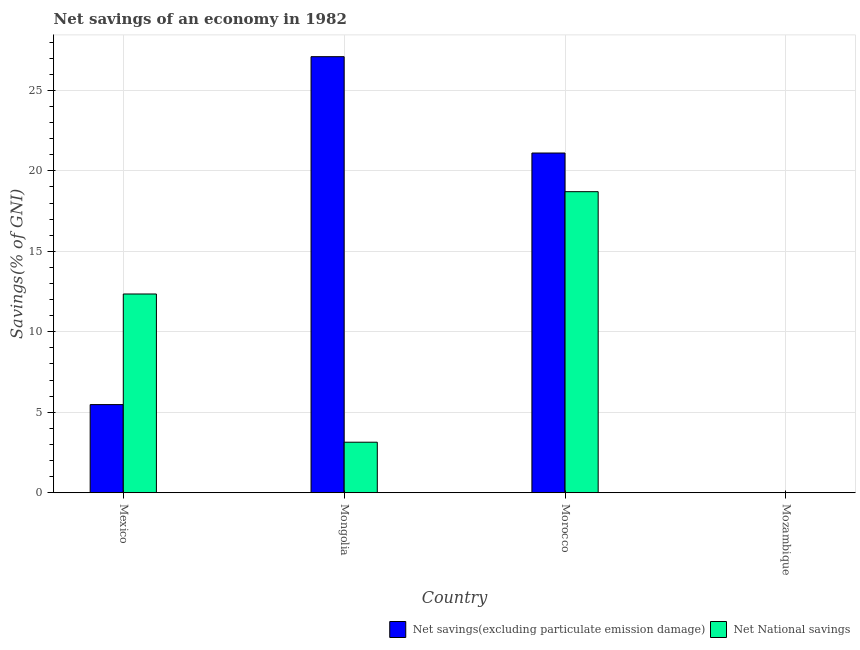What is the label of the 3rd group of bars from the left?
Keep it short and to the point. Morocco. What is the net national savings in Morocco?
Keep it short and to the point. 18.7. Across all countries, what is the maximum net national savings?
Your answer should be very brief. 18.7. Across all countries, what is the minimum net national savings?
Your answer should be very brief. 0. In which country was the net savings(excluding particulate emission damage) maximum?
Provide a short and direct response. Mongolia. What is the total net savings(excluding particulate emission damage) in the graph?
Provide a succinct answer. 53.67. What is the difference between the net national savings in Mexico and that in Morocco?
Give a very brief answer. -6.36. What is the difference between the net savings(excluding particulate emission damage) in Mexico and the net national savings in Mozambique?
Your answer should be very brief. 5.47. What is the average net national savings per country?
Your answer should be compact. 8.55. What is the difference between the net savings(excluding particulate emission damage) and net national savings in Mexico?
Make the answer very short. -6.87. In how many countries, is the net national savings greater than 9 %?
Make the answer very short. 2. What is the ratio of the net savings(excluding particulate emission damage) in Mongolia to that in Morocco?
Give a very brief answer. 1.28. Is the net savings(excluding particulate emission damage) in Mongolia less than that in Morocco?
Offer a terse response. No. What is the difference between the highest and the second highest net savings(excluding particulate emission damage)?
Keep it short and to the point. 5.99. What is the difference between the highest and the lowest net national savings?
Offer a terse response. 18.7. Is the sum of the net savings(excluding particulate emission damage) in Mongolia and Morocco greater than the maximum net national savings across all countries?
Your response must be concise. Yes. How many bars are there?
Your response must be concise. 6. Are the values on the major ticks of Y-axis written in scientific E-notation?
Offer a terse response. No. Does the graph contain grids?
Keep it short and to the point. Yes. How many legend labels are there?
Provide a succinct answer. 2. What is the title of the graph?
Provide a short and direct response. Net savings of an economy in 1982. Does "Secondary school" appear as one of the legend labels in the graph?
Give a very brief answer. No. What is the label or title of the Y-axis?
Ensure brevity in your answer.  Savings(% of GNI). What is the Savings(% of GNI) of Net savings(excluding particulate emission damage) in Mexico?
Your answer should be very brief. 5.47. What is the Savings(% of GNI) in Net National savings in Mexico?
Give a very brief answer. 12.35. What is the Savings(% of GNI) of Net savings(excluding particulate emission damage) in Mongolia?
Your response must be concise. 27.09. What is the Savings(% of GNI) of Net National savings in Mongolia?
Keep it short and to the point. 3.14. What is the Savings(% of GNI) in Net savings(excluding particulate emission damage) in Morocco?
Give a very brief answer. 21.1. What is the Savings(% of GNI) of Net National savings in Morocco?
Provide a succinct answer. 18.7. What is the Savings(% of GNI) in Net savings(excluding particulate emission damage) in Mozambique?
Your response must be concise. 0. Across all countries, what is the maximum Savings(% of GNI) of Net savings(excluding particulate emission damage)?
Provide a succinct answer. 27.09. Across all countries, what is the maximum Savings(% of GNI) of Net National savings?
Give a very brief answer. 18.7. Across all countries, what is the minimum Savings(% of GNI) in Net savings(excluding particulate emission damage)?
Keep it short and to the point. 0. What is the total Savings(% of GNI) in Net savings(excluding particulate emission damage) in the graph?
Provide a succinct answer. 53.67. What is the total Savings(% of GNI) of Net National savings in the graph?
Offer a terse response. 34.19. What is the difference between the Savings(% of GNI) of Net savings(excluding particulate emission damage) in Mexico and that in Mongolia?
Provide a short and direct response. -21.62. What is the difference between the Savings(% of GNI) of Net National savings in Mexico and that in Mongolia?
Your answer should be compact. 9.21. What is the difference between the Savings(% of GNI) in Net savings(excluding particulate emission damage) in Mexico and that in Morocco?
Your answer should be very brief. -15.63. What is the difference between the Savings(% of GNI) of Net National savings in Mexico and that in Morocco?
Keep it short and to the point. -6.36. What is the difference between the Savings(% of GNI) in Net savings(excluding particulate emission damage) in Mongolia and that in Morocco?
Offer a terse response. 5.99. What is the difference between the Savings(% of GNI) of Net National savings in Mongolia and that in Morocco?
Provide a succinct answer. -15.57. What is the difference between the Savings(% of GNI) of Net savings(excluding particulate emission damage) in Mexico and the Savings(% of GNI) of Net National savings in Mongolia?
Your answer should be compact. 2.34. What is the difference between the Savings(% of GNI) of Net savings(excluding particulate emission damage) in Mexico and the Savings(% of GNI) of Net National savings in Morocco?
Your answer should be compact. -13.23. What is the difference between the Savings(% of GNI) in Net savings(excluding particulate emission damage) in Mongolia and the Savings(% of GNI) in Net National savings in Morocco?
Your answer should be very brief. 8.39. What is the average Savings(% of GNI) in Net savings(excluding particulate emission damage) per country?
Provide a short and direct response. 13.42. What is the average Savings(% of GNI) of Net National savings per country?
Offer a terse response. 8.55. What is the difference between the Savings(% of GNI) of Net savings(excluding particulate emission damage) and Savings(% of GNI) of Net National savings in Mexico?
Provide a short and direct response. -6.87. What is the difference between the Savings(% of GNI) of Net savings(excluding particulate emission damage) and Savings(% of GNI) of Net National savings in Mongolia?
Your answer should be compact. 23.95. What is the difference between the Savings(% of GNI) of Net savings(excluding particulate emission damage) and Savings(% of GNI) of Net National savings in Morocco?
Your response must be concise. 2.4. What is the ratio of the Savings(% of GNI) in Net savings(excluding particulate emission damage) in Mexico to that in Mongolia?
Give a very brief answer. 0.2. What is the ratio of the Savings(% of GNI) of Net National savings in Mexico to that in Mongolia?
Keep it short and to the point. 3.93. What is the ratio of the Savings(% of GNI) in Net savings(excluding particulate emission damage) in Mexico to that in Morocco?
Offer a very short reply. 0.26. What is the ratio of the Savings(% of GNI) of Net National savings in Mexico to that in Morocco?
Give a very brief answer. 0.66. What is the ratio of the Savings(% of GNI) of Net savings(excluding particulate emission damage) in Mongolia to that in Morocco?
Keep it short and to the point. 1.28. What is the ratio of the Savings(% of GNI) of Net National savings in Mongolia to that in Morocco?
Your answer should be very brief. 0.17. What is the difference between the highest and the second highest Savings(% of GNI) in Net savings(excluding particulate emission damage)?
Your response must be concise. 5.99. What is the difference between the highest and the second highest Savings(% of GNI) of Net National savings?
Ensure brevity in your answer.  6.36. What is the difference between the highest and the lowest Savings(% of GNI) of Net savings(excluding particulate emission damage)?
Offer a terse response. 27.09. What is the difference between the highest and the lowest Savings(% of GNI) in Net National savings?
Offer a very short reply. 18.7. 